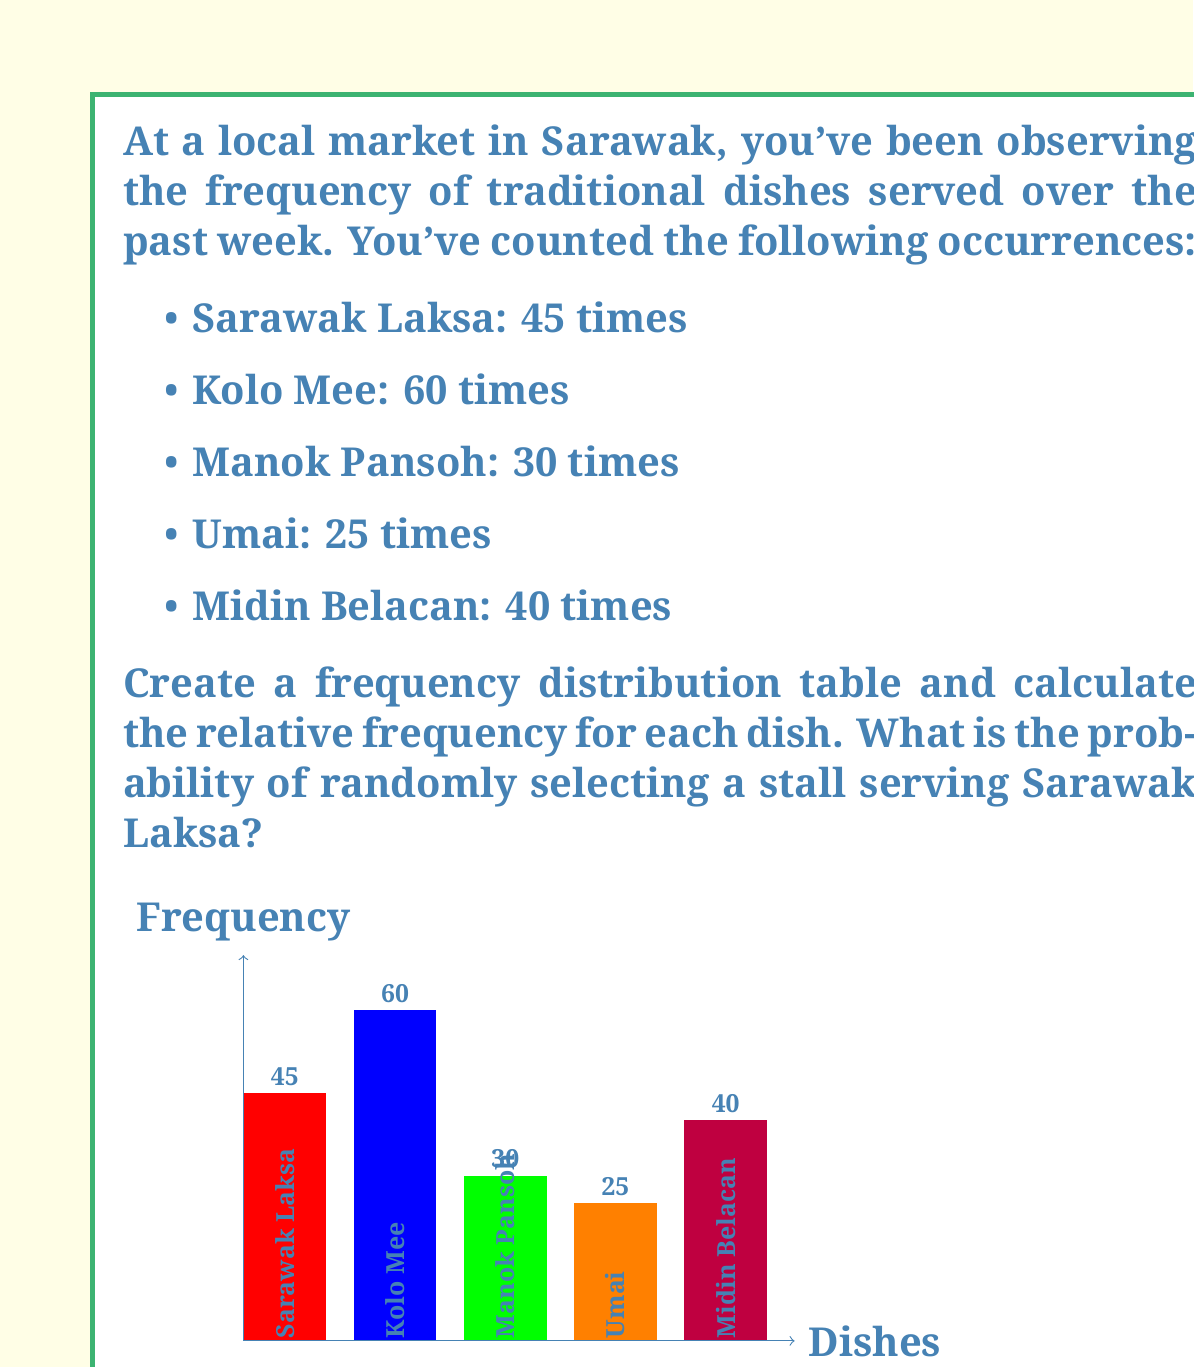Could you help me with this problem? Let's approach this step-by-step:

1) First, we need to calculate the total number of observations:
   $$ \text{Total} = 45 + 60 + 30 + 25 + 40 = 200 $$

2) Now, we can create a frequency distribution table and calculate the relative frequency for each dish:

   | Dish          | Frequency ($f$) | Relative Frequency ($f_r = \frac{f}{\text{Total}}$) |
   |---------------|-----------------|-----------------------------------------------------|
   | Sarawak Laksa | 45              | $\frac{45}{200} = 0.225$ or 22.5%                   |
   | Kolo Mee      | 60              | $\frac{60}{200} = 0.300$ or 30.0%                   |
   | Manok Pansoh  | 30              | $\frac{30}{200} = 0.150$ or 15.0%                   |
   | Umai          | 25              | $\frac{25}{200} = 0.125$ or 12.5%                   |
   | Midin Belacan | 40              | $\frac{40}{200} = 0.200$ or 20.0%                   |
   | Total         | 200             | 1.000 or 100%                                       |

3) The probability of randomly selecting a stall serving Sarawak Laksa is equal to its relative frequency:

   $$ P(\text{Sarawak Laksa}) = \frac{45}{200} = 0.225 \text{ or } 22.5\% $$

This means that if you were to randomly select a stall from this market, there's a 22.5% chance it would be serving Sarawak Laksa.
Answer: 0.225 or 22.5% 